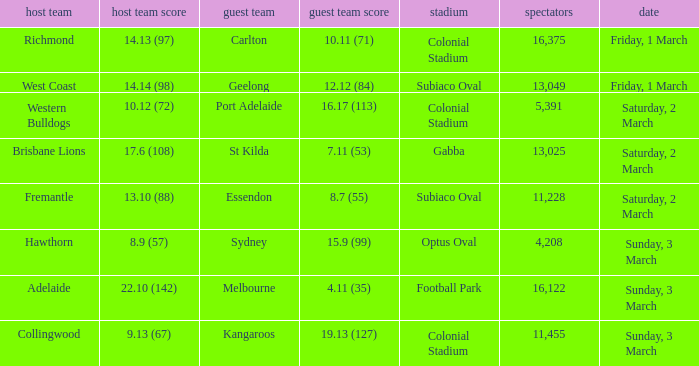What was the ground for away team essendon? Subiaco Oval. 